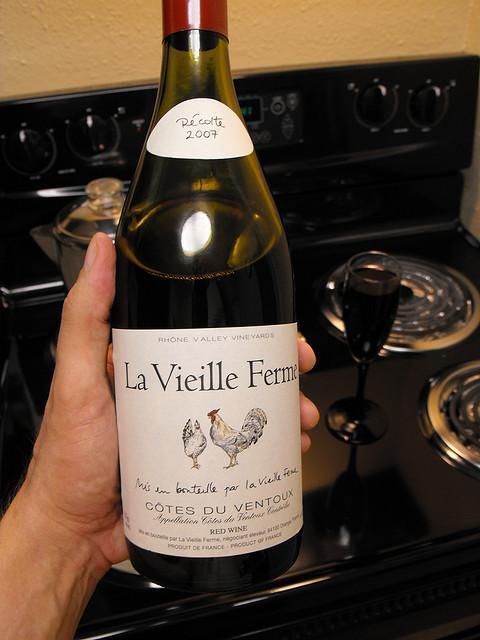Verify the accuracy of this image caption: "The oven is at the right side of the person.".
Answer yes or no. No. 